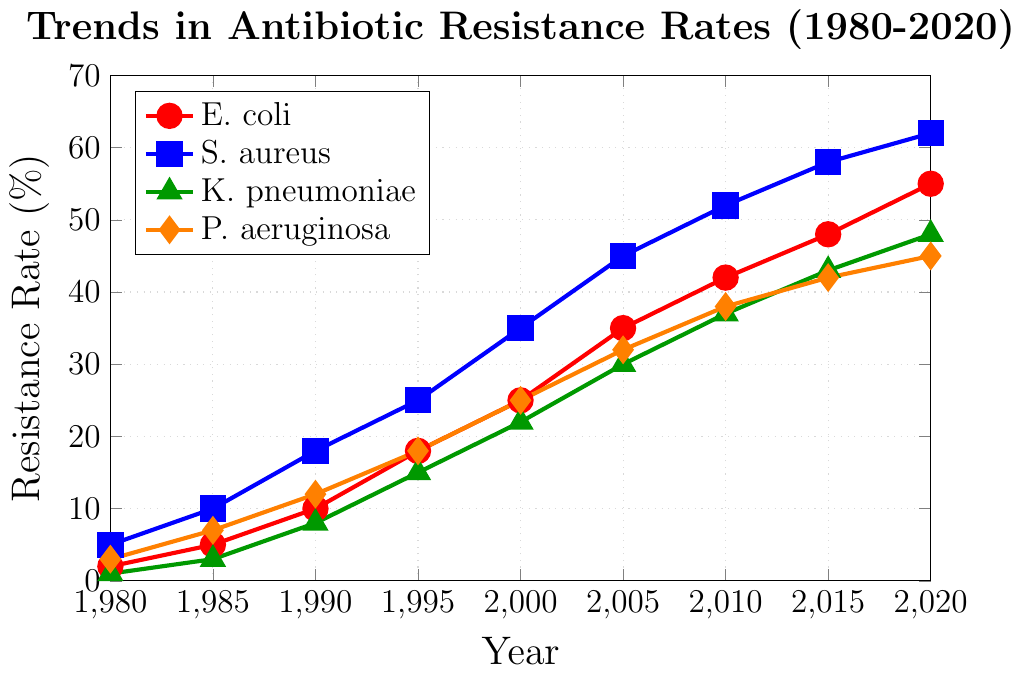Which bacterial species shows the highest antibiotic resistance rate in 2020? By looking at the highest point in 2020 for each line, we see that S. aureus has the highest value at 62%.
Answer: S. aureus What is the difference in resistance rates between E. coli and K. pneumoniae in 1990? In 1990, the resistance rate for E. coli is 10% and for K. pneumoniae is 8%. The difference is 10% - 8%.
Answer: 2% Between which consecutive years did P. aeruginosa show the largest increase in resistance rate? By comparing the increases between each consecutive data point for P. aeruginosa, the largest increase is between 1985 (7%) to 1990 (12%), an increase of 5%.
Answer: 1985 to 1990 On average, how much did the resistance rate for S. aureus increase per decade from 1980 to 2020? Over 40 years (1980 to 2020), the resistance rate for S. aureus increased from 5% to 62%, a total increase of 57%. Dividing this total increase by 4 decades gives the average increase per decade: 57% / 4 = 14.25%.
Answer: 14.25% Between 2005 and 2015, which bacterial species showed the smallest increase in resistance rates? For each species: E. coli increased from 35% to 48% (13%), S. aureus from 45% to 58% (13%), K. pneumoniae from 30% to 43% (13%), and P. aeruginosa from 32% to 42% (10%). P. aeruginosa has the smallest increase.
Answer: P. aeruginosa Which bacterial species had similar resistance rates in the year 2000? In 2000, E. coli had a resistance rate of 25%, and P. aeruginosa had 25%. Both had the same rate.
Answer: E. coli and P. aeruginosa How much has the resistance rate of K. pneumoniae increased from 1980 to 2020? In 1980, K. pneumoniae had a resistance rate of 1%, and in 2020 it is 48%. The increase is 48% - 1% = 47%.
Answer: 47% Which bacterial species showed a consistent increase in resistance rates throughout the entire period? By observing the trends, all four species (E. coli, S. aureus, K. pneumoniae, P. aeruginosa) show consistent increases with no declines throughout the 1980 to 2020 period.
Answer: All four species What was the resistance rate of K. pneumoniae in 1995 and how does it compare to that of S. aureus in the same year? In 1995, K. pneumoniae had a resistance rate of 15% and S. aureus had a resistance rate of 25%. So, K. pneumoniae's resistance rate is 10% lower than S. aureus in that year.
Answer: 10% lower Which bacterial species has the steepest increase in resistance rate from 1980 to 1985? Analyzing the increase for all species between 1980 to 1985: E. coli increased by 3%, S. aureus by 5%, K. pneumoniae by 2%, and P. aeruginosa by 4%. S. aureus has the steepest increase at 5%.
Answer: S. aureus 